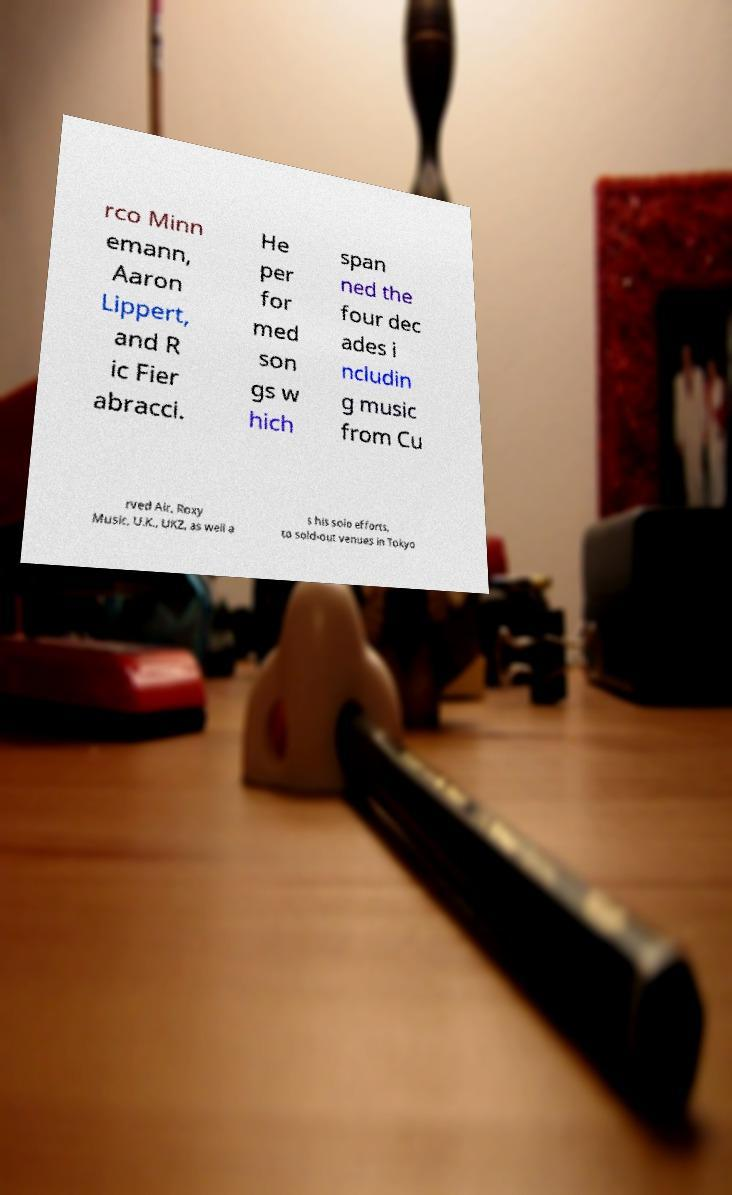Could you extract and type out the text from this image? rco Minn emann, Aaron Lippert, and R ic Fier abracci. He per for med son gs w hich span ned the four dec ades i ncludin g music from Cu rved Air, Roxy Music, U.K., UKZ, as well a s his solo efforts, to sold-out venues in Tokyo 